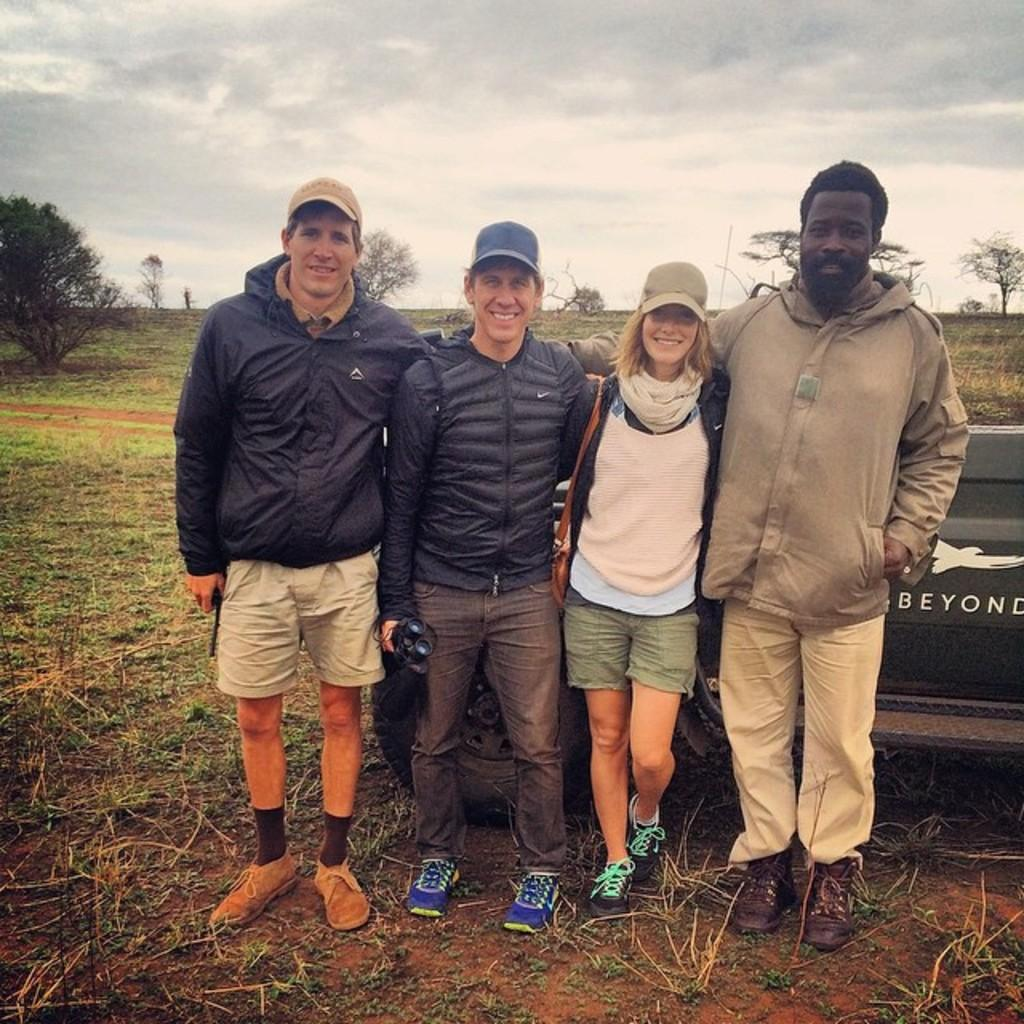How many people are in the image? There are four persons in the image. What are the persons doing in the image? The persons are standing near a jeep. What can be seen in the background of the image? There is a grassland, a tree, and a cloudy sky in the background of the image. What type of bottle is being used to film the actor in the image? There is no bottle or actor present in the image; it features four persons standing near a jeep with a grassland, a tree, and a cloudy sky in the background. 